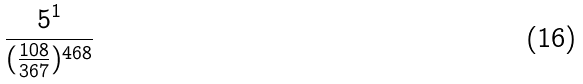Convert formula to latex. <formula><loc_0><loc_0><loc_500><loc_500>\frac { 5 ^ { 1 } } { ( \frac { 1 0 8 } { 3 6 7 } ) ^ { 4 6 8 } }</formula> 